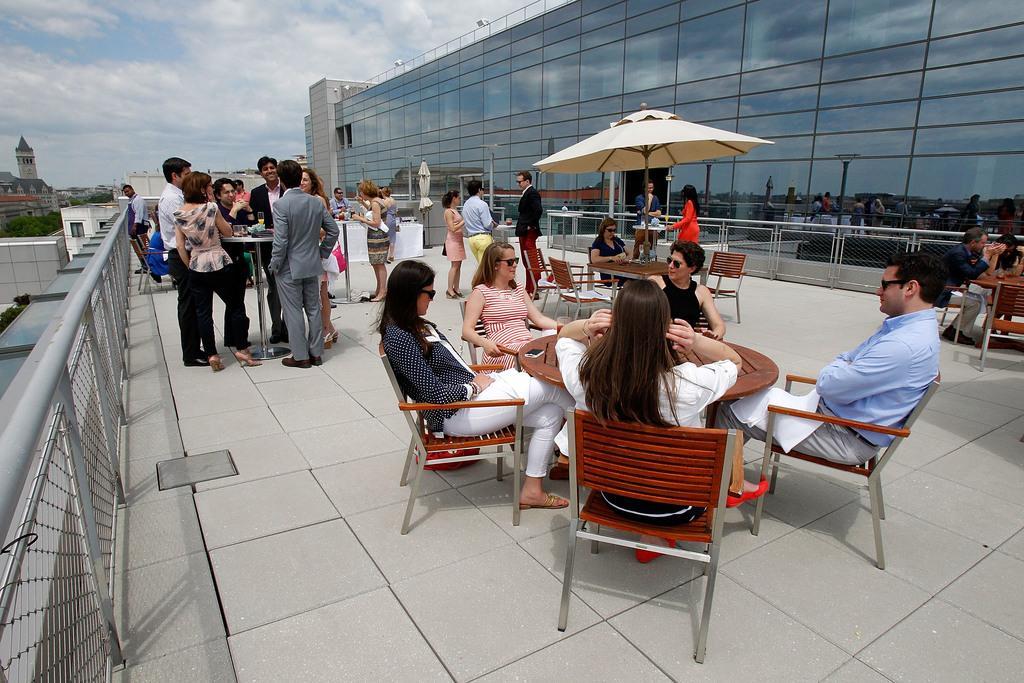In one or two sentences, can you explain what this image depicts? In this image I can see people were few of them are standing and few are sitting on chairs. I can also see few buildings, trees and clear view of sky. 